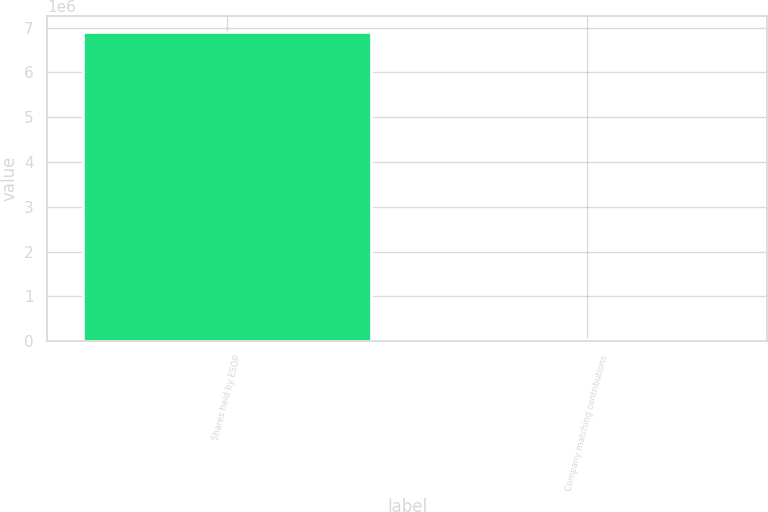Convert chart to OTSL. <chart><loc_0><loc_0><loc_500><loc_500><bar_chart><fcel>Shares held by ESOP<fcel>Company matching contributions<nl><fcel>6.91144e+06<fcel>57766<nl></chart> 